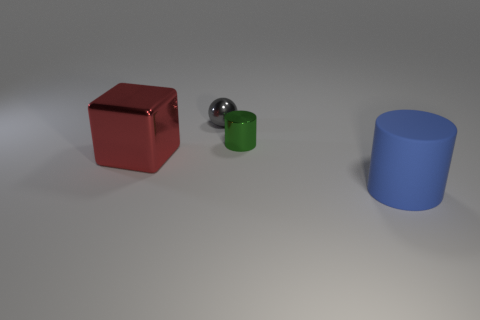Add 1 blue matte cylinders. How many objects exist? 5 Subtract all blocks. How many objects are left? 3 Add 1 red blocks. How many red blocks are left? 2 Add 3 small gray spheres. How many small gray spheres exist? 4 Subtract 0 brown cubes. How many objects are left? 4 Subtract all big red shiny cubes. Subtract all small cylinders. How many objects are left? 2 